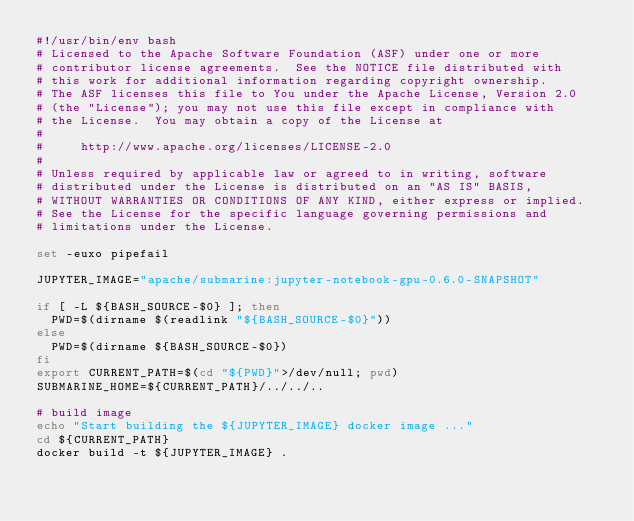Convert code to text. <code><loc_0><loc_0><loc_500><loc_500><_Bash_>#!/usr/bin/env bash
# Licensed to the Apache Software Foundation (ASF) under one or more
# contributor license agreements.  See the NOTICE file distributed with
# this work for additional information regarding copyright ownership.
# The ASF licenses this file to You under the Apache License, Version 2.0
# (the "License"); you may not use this file except in compliance with
# the License.  You may obtain a copy of the License at
#
#     http://www.apache.org/licenses/LICENSE-2.0
#
# Unless required by applicable law or agreed to in writing, software
# distributed under the License is distributed on an "AS IS" BASIS,
# WITHOUT WARRANTIES OR CONDITIONS OF ANY KIND, either express or implied.
# See the License for the specific language governing permissions and
# limitations under the License.

set -euxo pipefail

JUPYTER_IMAGE="apache/submarine:jupyter-notebook-gpu-0.6.0-SNAPSHOT"

if [ -L ${BASH_SOURCE-$0} ]; then
  PWD=$(dirname $(readlink "${BASH_SOURCE-$0}"))
else
  PWD=$(dirname ${BASH_SOURCE-$0})
fi
export CURRENT_PATH=$(cd "${PWD}">/dev/null; pwd)
SUBMARINE_HOME=${CURRENT_PATH}/../../..

# build image
echo "Start building the ${JUPYTER_IMAGE} docker image ..."
cd ${CURRENT_PATH}
docker build -t ${JUPYTER_IMAGE} .
</code> 